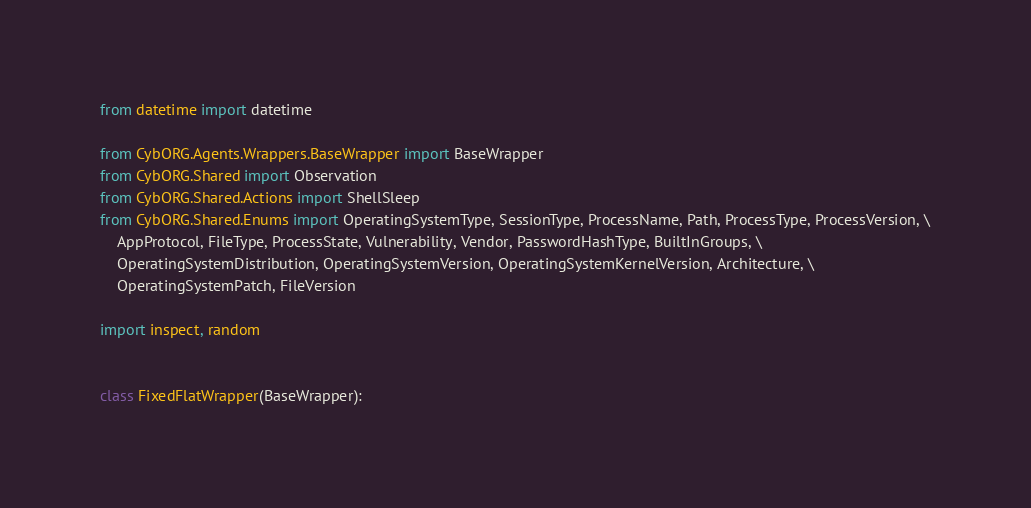Convert code to text. <code><loc_0><loc_0><loc_500><loc_500><_Python_>from datetime import datetime

from CybORG.Agents.Wrappers.BaseWrapper import BaseWrapper
from CybORG.Shared import Observation
from CybORG.Shared.Actions import ShellSleep
from CybORG.Shared.Enums import OperatingSystemType, SessionType, ProcessName, Path, ProcessType, ProcessVersion, \
    AppProtocol, FileType, ProcessState, Vulnerability, Vendor, PasswordHashType, BuiltInGroups, \
    OperatingSystemDistribution, OperatingSystemVersion, OperatingSystemKernelVersion, Architecture, \
    OperatingSystemPatch, FileVersion

import inspect, random


class FixedFlatWrapper(BaseWrapper):</code> 